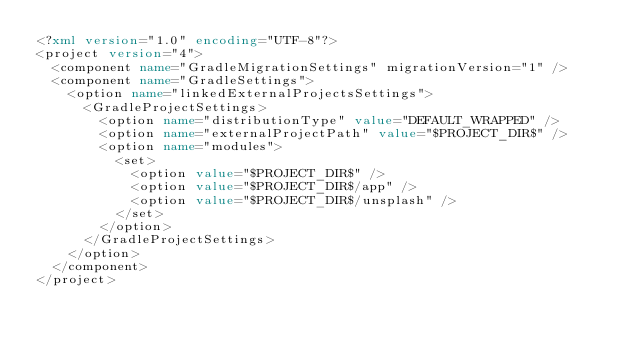Convert code to text. <code><loc_0><loc_0><loc_500><loc_500><_XML_><?xml version="1.0" encoding="UTF-8"?>
<project version="4">
  <component name="GradleMigrationSettings" migrationVersion="1" />
  <component name="GradleSettings">
    <option name="linkedExternalProjectsSettings">
      <GradleProjectSettings>
        <option name="distributionType" value="DEFAULT_WRAPPED" />
        <option name="externalProjectPath" value="$PROJECT_DIR$" />
        <option name="modules">
          <set>
            <option value="$PROJECT_DIR$" />
            <option value="$PROJECT_DIR$/app" />
            <option value="$PROJECT_DIR$/unsplash" />
          </set>
        </option>
      </GradleProjectSettings>
    </option>
  </component>
</project></code> 